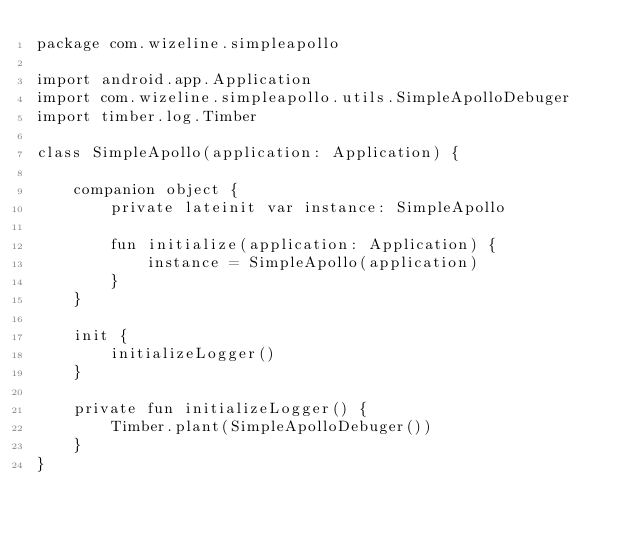Convert code to text. <code><loc_0><loc_0><loc_500><loc_500><_Kotlin_>package com.wizeline.simpleapollo

import android.app.Application
import com.wizeline.simpleapollo.utils.SimpleApolloDebuger
import timber.log.Timber

class SimpleApollo(application: Application) {

    companion object {
        private lateinit var instance: SimpleApollo

        fun initialize(application: Application) {
            instance = SimpleApollo(application)
        }
    }

    init {
        initializeLogger()
    }

    private fun initializeLogger() {
        Timber.plant(SimpleApolloDebuger())
    }
}
</code> 